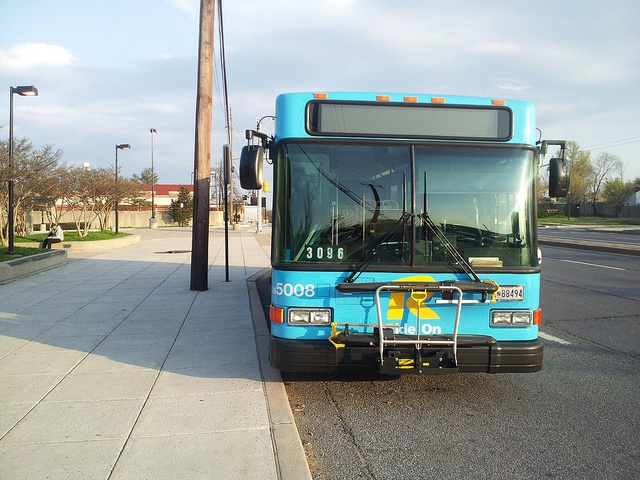Describe the objects in this image and their specific colors. I can see bus in lightblue, black, gray, darkgray, and cyan tones and people in lightblue, black, beige, and gray tones in this image. 